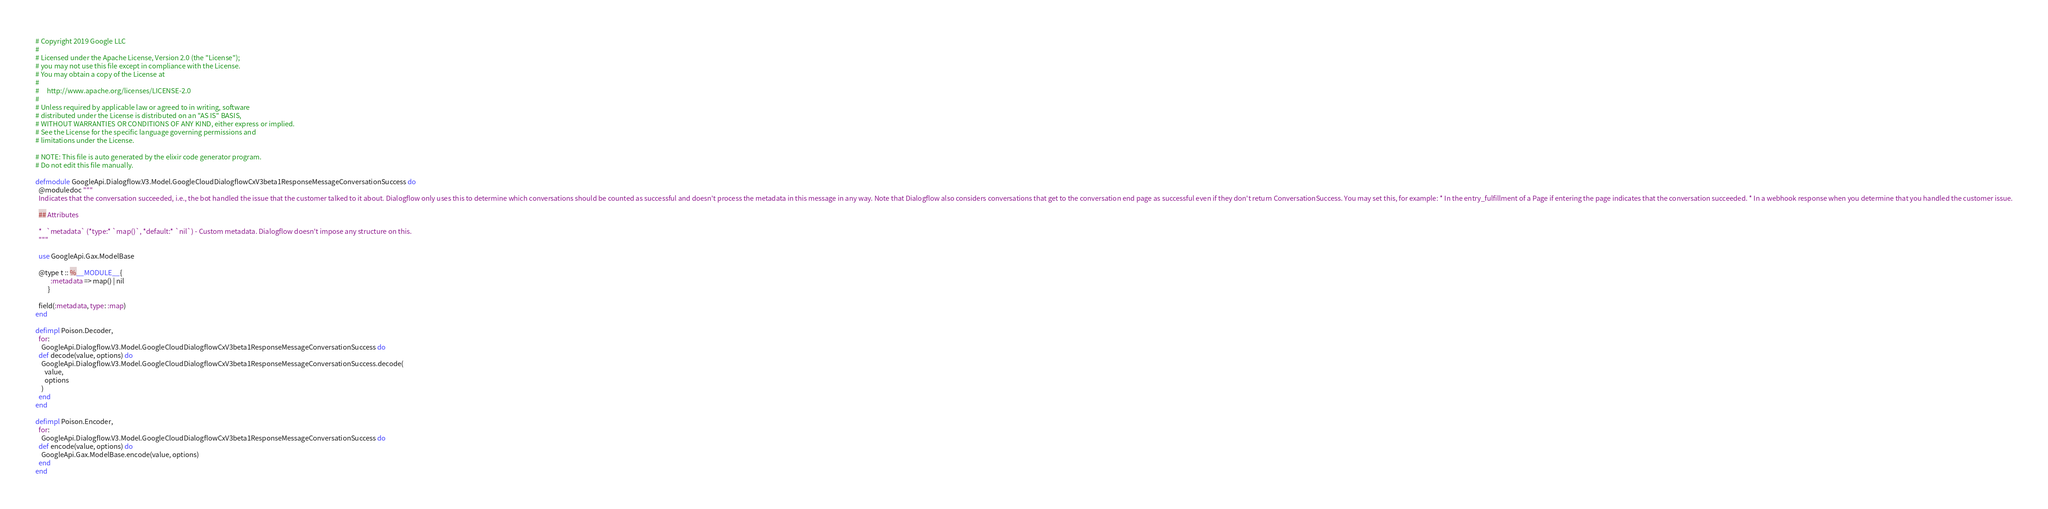<code> <loc_0><loc_0><loc_500><loc_500><_Elixir_># Copyright 2019 Google LLC
#
# Licensed under the Apache License, Version 2.0 (the "License");
# you may not use this file except in compliance with the License.
# You may obtain a copy of the License at
#
#     http://www.apache.org/licenses/LICENSE-2.0
#
# Unless required by applicable law or agreed to in writing, software
# distributed under the License is distributed on an "AS IS" BASIS,
# WITHOUT WARRANTIES OR CONDITIONS OF ANY KIND, either express or implied.
# See the License for the specific language governing permissions and
# limitations under the License.

# NOTE: This file is auto generated by the elixir code generator program.
# Do not edit this file manually.

defmodule GoogleApi.Dialogflow.V3.Model.GoogleCloudDialogflowCxV3beta1ResponseMessageConversationSuccess do
  @moduledoc """
  Indicates that the conversation succeeded, i.e., the bot handled the issue that the customer talked to it about. Dialogflow only uses this to determine which conversations should be counted as successful and doesn't process the metadata in this message in any way. Note that Dialogflow also considers conversations that get to the conversation end page as successful even if they don't return ConversationSuccess. You may set this, for example: * In the entry_fulfillment of a Page if entering the page indicates that the conversation succeeded. * In a webhook response when you determine that you handled the customer issue.

  ## Attributes

  *   `metadata` (*type:* `map()`, *default:* `nil`) - Custom metadata. Dialogflow doesn't impose any structure on this.
  """

  use GoogleApi.Gax.ModelBase

  @type t :: %__MODULE__{
          :metadata => map() | nil
        }

  field(:metadata, type: :map)
end

defimpl Poison.Decoder,
  for:
    GoogleApi.Dialogflow.V3.Model.GoogleCloudDialogflowCxV3beta1ResponseMessageConversationSuccess do
  def decode(value, options) do
    GoogleApi.Dialogflow.V3.Model.GoogleCloudDialogflowCxV3beta1ResponseMessageConversationSuccess.decode(
      value,
      options
    )
  end
end

defimpl Poison.Encoder,
  for:
    GoogleApi.Dialogflow.V3.Model.GoogleCloudDialogflowCxV3beta1ResponseMessageConversationSuccess do
  def encode(value, options) do
    GoogleApi.Gax.ModelBase.encode(value, options)
  end
end
</code> 